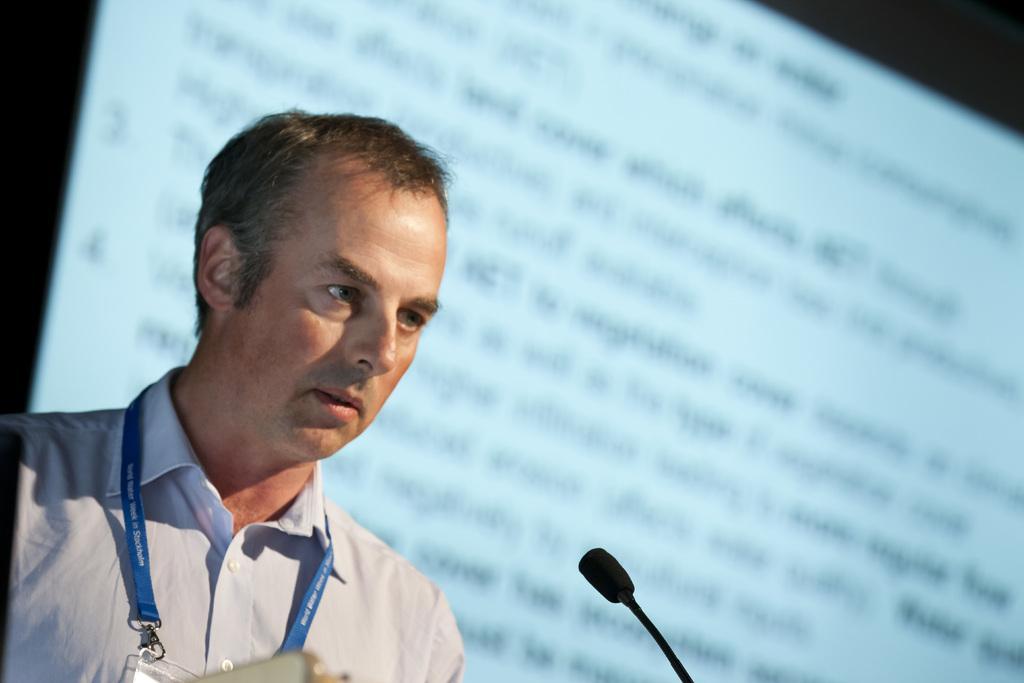Can you describe this image briefly? There is one man wearing a white color shirt and an ID card as we can see in the bottom left corner of this image. There is a Mic at the bottom of this image and the screen is in the background. 